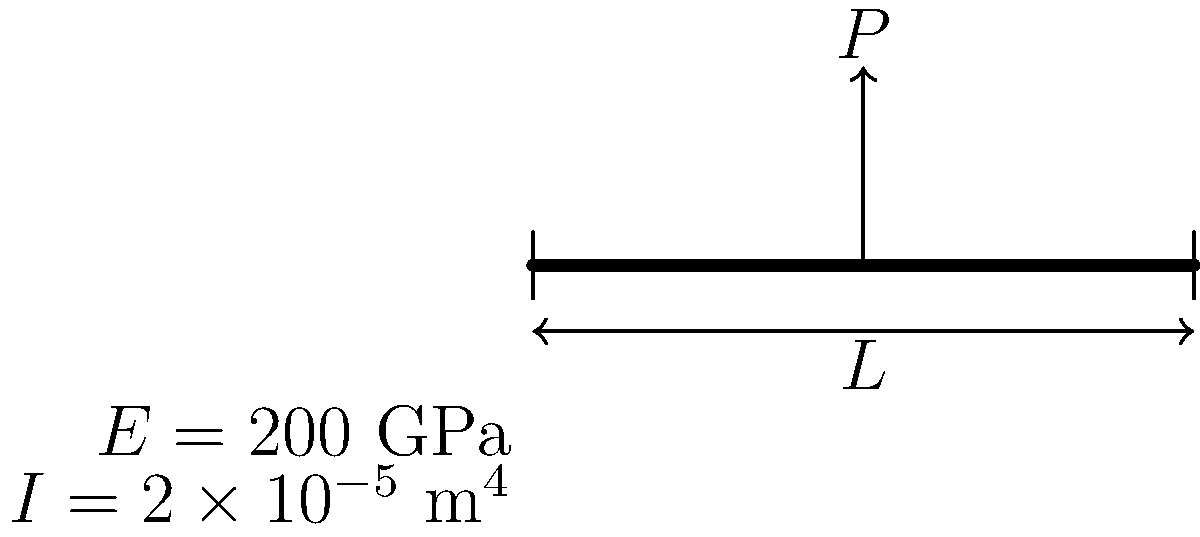A simply supported steel beam with length $L = 5$ m is subjected to a point load $P = 50$ kN at its midspan. The beam has a Young's modulus $E = 200$ GPa and a moment of inertia $I = 2 \times 10^{-5}$ m$^4$. Calculate the maximum deflection of the beam. To calculate the maximum deflection of a simply supported beam with a point load at the midspan, we can use the following steps:

1. Recall the formula for maximum deflection in this case:
   $$\delta_{max} = \frac{PL^3}{48EI}$$
   
   Where:
   $\delta_{max}$ = maximum deflection
   $P$ = point load
   $L$ = beam length
   $E$ = Young's modulus
   $I$ = moment of inertia

2. Substitute the given values:
   $P = 50$ kN = $50,000$ N
   $L = 5$ m
   $E = 200$ GPa = $200 \times 10^9$ Pa
   $I = 2 \times 10^{-5}$ m$^4$

3. Calculate:
   $$\delta_{max} = \frac{50,000 \times 5^3}{48 \times 200 \times 10^9 \times 2 \times 10^{-5}}$$

4. Simplify:
   $$\delta_{max} = \frac{50,000 \times 125}{19,200 \times 10^9 \times 10^{-5}}$$
   $$\delta_{max} = \frac{6,250,000}{192,000,000} = 0.0325521$ m

5. Convert to millimeters:
   $$\delta_{max} = 0.0325521 \times 1000 = 32.5521$ mm

Therefore, the maximum deflection of the beam is approximately 32.55 mm.
Answer: 32.55 mm 